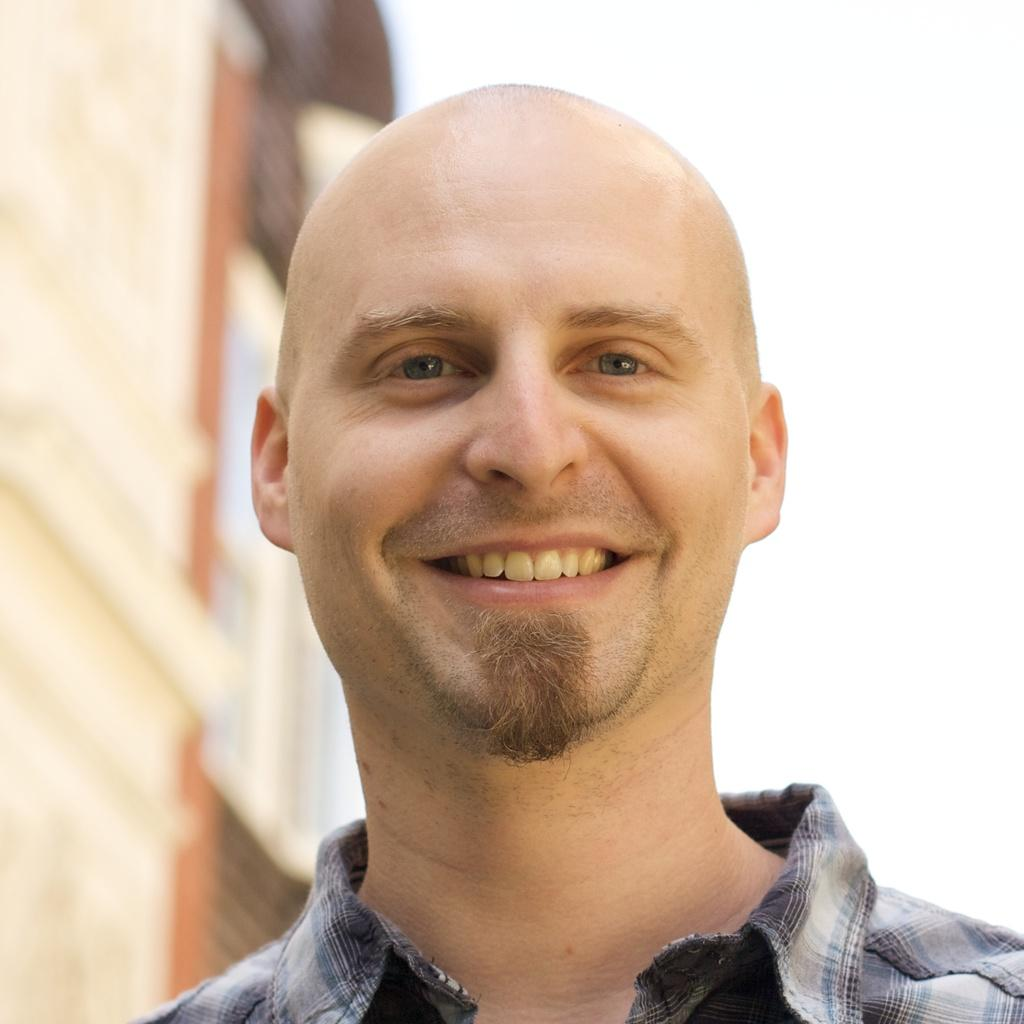What is the appearance of the man in the image? There is a bald-headed man in the image. Where is the man positioned in the image? The man is standing in the front. What is the man's facial expression in the image? The man is smiling. What can be seen in the background of the image? There is a building in the background of the image. What is visible above the building in the image? The sky is visible above the building. What type of spot does the man's partner have on their shirt in the image? There is no partner present in the image, and therefore no shirt or spot can be observed. 